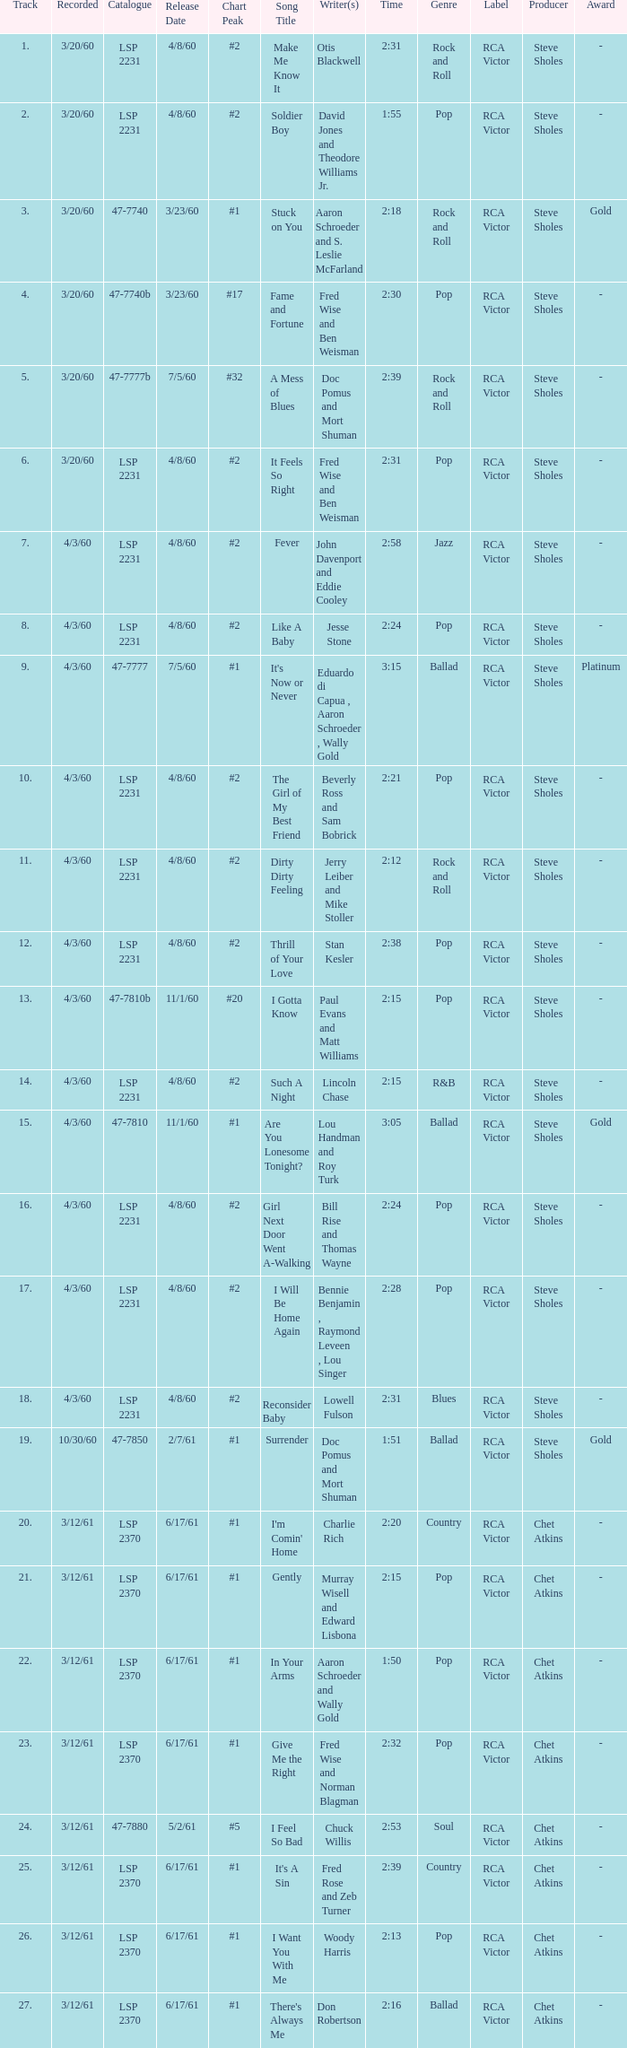What is the time of songs that have the writer Aaron Schroeder and Wally Gold? 1:50. Would you mind parsing the complete table? {'header': ['Track', 'Recorded', 'Catalogue', 'Release Date', 'Chart Peak', 'Song Title', 'Writer(s)', 'Time', 'Genre', 'Label', 'Producer', 'Award'], 'rows': [['1.', '3/20/60', 'LSP 2231', '4/8/60', '#2', 'Make Me Know It', 'Otis Blackwell', '2:31', 'Rock and Roll', 'RCA Victor', 'Steve Sholes', '-'], ['2.', '3/20/60', 'LSP 2231', '4/8/60', '#2', 'Soldier Boy', 'David Jones and Theodore Williams Jr.', '1:55', 'Pop', 'RCA Victor', 'Steve Sholes', '-'], ['3.', '3/20/60', '47-7740', '3/23/60', '#1', 'Stuck on You', 'Aaron Schroeder and S. Leslie McFarland', '2:18', 'Rock and Roll', 'RCA Victor', 'Steve Sholes', 'Gold'], ['4.', '3/20/60', '47-7740b', '3/23/60', '#17', 'Fame and Fortune', 'Fred Wise and Ben Weisman', '2:30', 'Pop', 'RCA Victor', 'Steve Sholes', '-'], ['5.', '3/20/60', '47-7777b', '7/5/60', '#32', 'A Mess of Blues', 'Doc Pomus and Mort Shuman', '2:39', 'Rock and Roll', 'RCA Victor', 'Steve Sholes', '-'], ['6.', '3/20/60', 'LSP 2231', '4/8/60', '#2', 'It Feels So Right', 'Fred Wise and Ben Weisman', '2:31', 'Pop', 'RCA Victor', 'Steve Sholes', '-'], ['7.', '4/3/60', 'LSP 2231', '4/8/60', '#2', 'Fever', 'John Davenport and Eddie Cooley', '2:58', 'Jazz', 'RCA Victor', 'Steve Sholes', '-'], ['8.', '4/3/60', 'LSP 2231', '4/8/60', '#2', 'Like A Baby', 'Jesse Stone', '2:24', 'Pop', 'RCA Victor', 'Steve Sholes', '-'], ['9.', '4/3/60', '47-7777', '7/5/60', '#1', "It's Now or Never", 'Eduardo di Capua , Aaron Schroeder , Wally Gold', '3:15', 'Ballad', 'RCA Victor', 'Steve Sholes', 'Platinum'], ['10.', '4/3/60', 'LSP 2231', '4/8/60', '#2', 'The Girl of My Best Friend', 'Beverly Ross and Sam Bobrick', '2:21', 'Pop', 'RCA Victor', 'Steve Sholes', '-'], ['11.', '4/3/60', 'LSP 2231', '4/8/60', '#2', 'Dirty Dirty Feeling', 'Jerry Leiber and Mike Stoller', '2:12', 'Rock and Roll', 'RCA Victor', 'Steve Sholes', '-'], ['12.', '4/3/60', 'LSP 2231', '4/8/60', '#2', 'Thrill of Your Love', 'Stan Kesler', '2:38', 'Pop', 'RCA Victor', 'Steve Sholes', '-'], ['13.', '4/3/60', '47-7810b', '11/1/60', '#20', 'I Gotta Know', 'Paul Evans and Matt Williams', '2:15', 'Pop', 'RCA Victor', 'Steve Sholes', '-'], ['14.', '4/3/60', 'LSP 2231', '4/8/60', '#2', 'Such A Night', 'Lincoln Chase', '2:15', 'R&B', 'RCA Victor', 'Steve Sholes', '-'], ['15.', '4/3/60', '47-7810', '11/1/60', '#1', 'Are You Lonesome Tonight?', 'Lou Handman and Roy Turk', '3:05', 'Ballad', 'RCA Victor', 'Steve Sholes', 'Gold'], ['16.', '4/3/60', 'LSP 2231', '4/8/60', '#2', 'Girl Next Door Went A-Walking', 'Bill Rise and Thomas Wayne', '2:24', 'Pop', 'RCA Victor', 'Steve Sholes', '-'], ['17.', '4/3/60', 'LSP 2231', '4/8/60', '#2', 'I Will Be Home Again', 'Bennie Benjamin , Raymond Leveen , Lou Singer', '2:28', 'Pop', 'RCA Victor', 'Steve Sholes', '-'], ['18.', '4/3/60', 'LSP 2231', '4/8/60', '#2', 'Reconsider Baby', 'Lowell Fulson', '2:31', 'Blues', 'RCA Victor', 'Steve Sholes', '-'], ['19.', '10/30/60', '47-7850', '2/7/61', '#1', 'Surrender', 'Doc Pomus and Mort Shuman', '1:51', 'Ballad', 'RCA Victor', 'Steve Sholes', 'Gold'], ['20.', '3/12/61', 'LSP 2370', '6/17/61', '#1', "I'm Comin' Home", 'Charlie Rich', '2:20', 'Country', 'RCA Victor', 'Chet Atkins', '-'], ['21.', '3/12/61', 'LSP 2370', '6/17/61', '#1', 'Gently', 'Murray Wisell and Edward Lisbona', '2:15', 'Pop', 'RCA Victor', 'Chet Atkins', '-'], ['22.', '3/12/61', 'LSP 2370', '6/17/61', '#1', 'In Your Arms', 'Aaron Schroeder and Wally Gold', '1:50', 'Pop', 'RCA Victor', 'Chet Atkins', '-'], ['23.', '3/12/61', 'LSP 2370', '6/17/61', '#1', 'Give Me the Right', 'Fred Wise and Norman Blagman', '2:32', 'Pop', 'RCA Victor', 'Chet Atkins', '-'], ['24.', '3/12/61', '47-7880', '5/2/61', '#5', 'I Feel So Bad', 'Chuck Willis', '2:53', 'Soul', 'RCA Victor', 'Chet Atkins', '-'], ['25.', '3/12/61', 'LSP 2370', '6/17/61', '#1', "It's A Sin", 'Fred Rose and Zeb Turner', '2:39', 'Country', 'RCA Victor', 'Chet Atkins', '-'], ['26.', '3/12/61', 'LSP 2370', '6/17/61', '#1', 'I Want You With Me', 'Woody Harris', '2:13', 'Pop', 'RCA Victor', 'Chet Atkins', '-'], ['27.', '3/12/61', 'LSP 2370', '6/17/61', '#1', "There's Always Me", 'Don Robertson', '2:16', 'Ballad', 'RCA Victor', 'Chet Atkins', '-']]} 